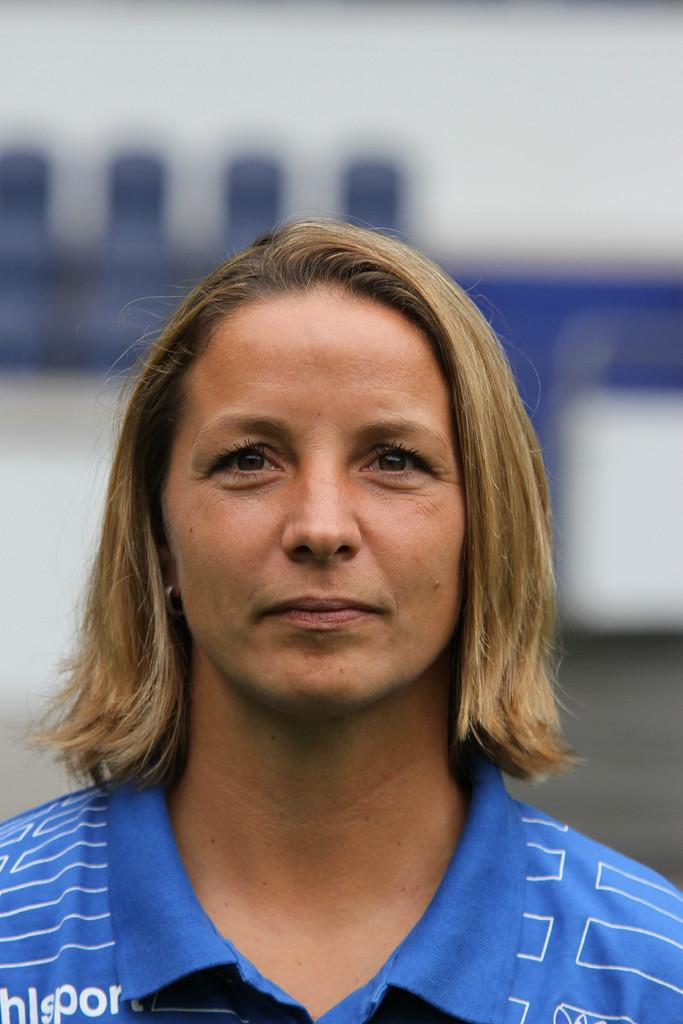What is the main subject of the image? The main subject of the image is a woman. What is the woman wearing in the image? The woman is wearing a blue t-shirt. Can you tell me how many yaks are present in the image? There are no yaks present in the image; it features a woman wearing a blue t-shirt. What type of growth is the woman experiencing in the image? There is no indication of any growth or change in the woman's appearance in the image. 